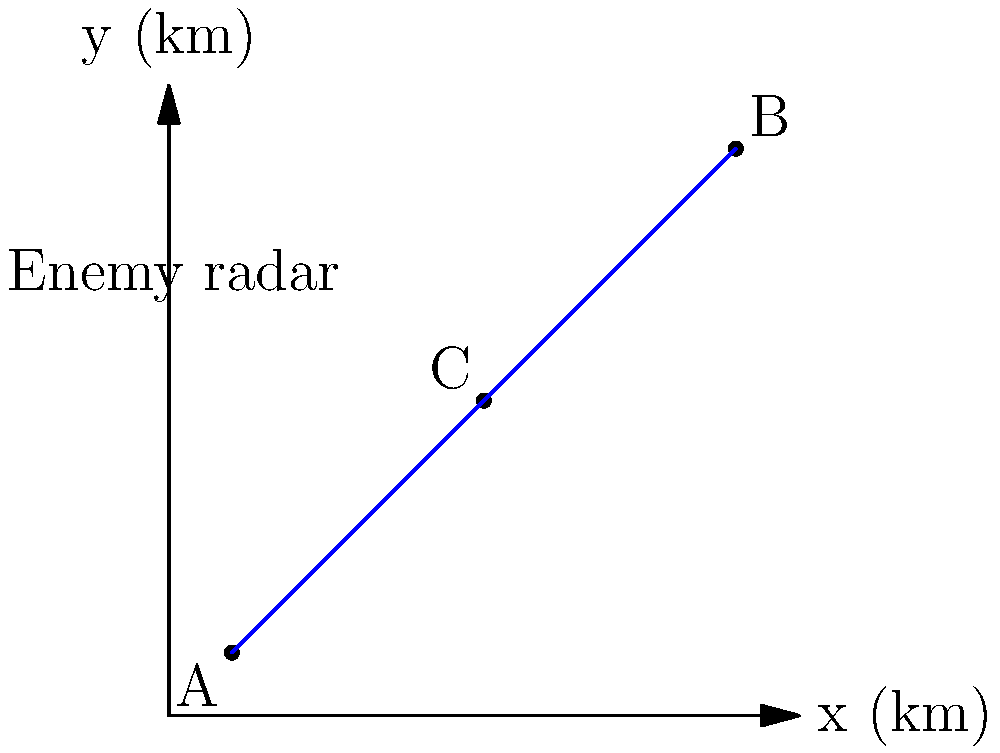A reconnaissance drone needs to fly from point A (1,1) to point B (9,9) while avoiding detection by an enemy radar located at (3,7). The drone's flight path consists of two straight segments passing through point C (5,5). Calculate the total flight distance of the drone using this path. Round your answer to two decimal places. To solve this problem, we need to follow these steps:

1) First, we need to calculate the distances AC and CB using the distance formula between two points:
   $d = \sqrt{(x_2-x_1)^2 + (y_2-y_1)^2}$

2) For AC:
   $AC = \sqrt{(5-1)^2 + (5-1)^2} = \sqrt{16 + 16} = \sqrt{32} = 4\sqrt{2}$

3) For CB:
   $CB = \sqrt{(9-5)^2 + (9-5)^2} = \sqrt{16 + 16} = \sqrt{32} = 4\sqrt{2}$

4) The total distance is the sum of AC and CB:
   $Total Distance = AC + CB = 4\sqrt{2} + 4\sqrt{2} = 8\sqrt{2}$

5) To get the numerical value, we calculate:
   $8\sqrt{2} \approx 11.3137$

6) Rounding to two decimal places:
   $11.31$ km

This flight path allows the drone to avoid flying directly over the enemy radar, potentially reducing the risk of detection.
Answer: 11.31 km 